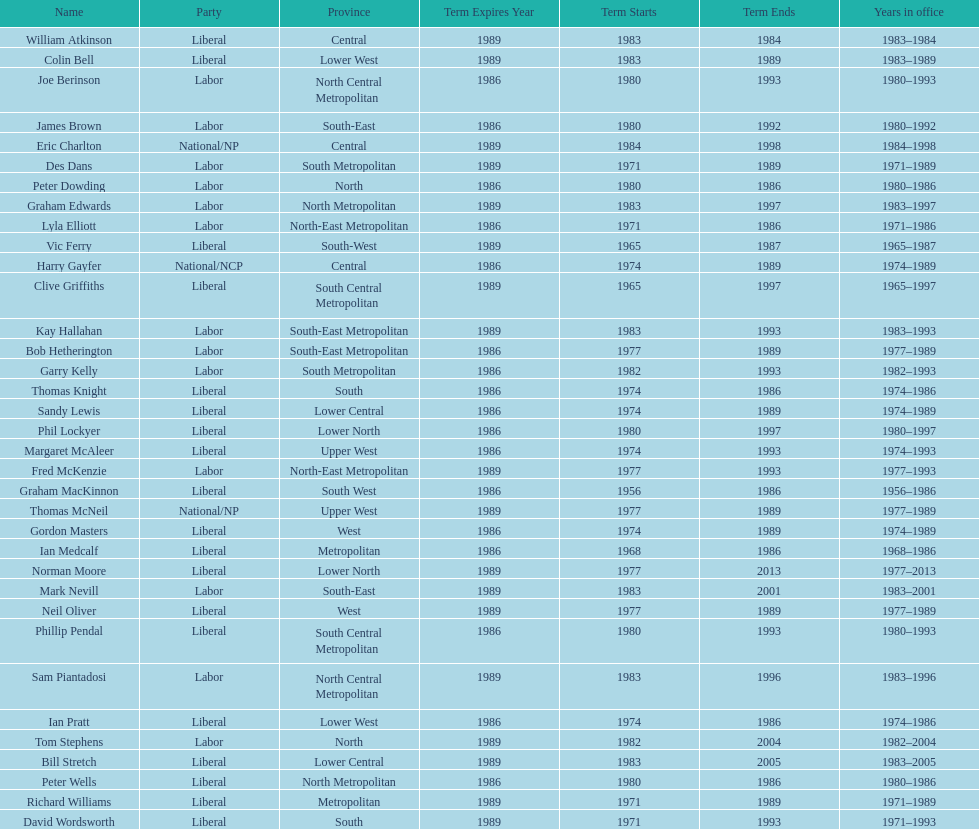What is the number of people in the liberal party? 19. Write the full table. {'header': ['Name', 'Party', 'Province', 'Term Expires Year', 'Term Starts', 'Term Ends', 'Years in office'], 'rows': [['William Atkinson', 'Liberal', 'Central', '1989', '1983', '1984', '1983–1984'], ['Colin Bell', 'Liberal', 'Lower West', '1989', '1983', '1989', '1983–1989'], ['Joe Berinson', 'Labor', 'North Central Metropolitan', '1986', '1980', '1993', '1980–1993'], ['James Brown', 'Labor', 'South-East', '1986', '1980', '1992', '1980–1992'], ['Eric Charlton', 'National/NP', 'Central', '1989', '1984', '1998', '1984–1998'], ['Des Dans', 'Labor', 'South Metropolitan', '1989', '1971', '1989', '1971–1989'], ['Peter Dowding', 'Labor', 'North', '1986', '1980', '1986', '1980–1986'], ['Graham Edwards', 'Labor', 'North Metropolitan', '1989', '1983', '1997', '1983–1997'], ['Lyla Elliott', 'Labor', 'North-East Metropolitan', '1986', '1971', '1986', '1971–1986'], ['Vic Ferry', 'Liberal', 'South-West', '1989', '1965', '1987', '1965–1987'], ['Harry Gayfer', 'National/NCP', 'Central', '1986', '1974', '1989', '1974–1989'], ['Clive Griffiths', 'Liberal', 'South Central Metropolitan', '1989', '1965', '1997', '1965–1997'], ['Kay Hallahan', 'Labor', 'South-East Metropolitan', '1989', '1983', '1993', '1983–1993'], ['Bob Hetherington', 'Labor', 'South-East Metropolitan', '1986', '1977', '1989', '1977–1989'], ['Garry Kelly', 'Labor', 'South Metropolitan', '1986', '1982', '1993', '1982–1993'], ['Thomas Knight', 'Liberal', 'South', '1986', '1974', '1986', '1974–1986'], ['Sandy Lewis', 'Liberal', 'Lower Central', '1986', '1974', '1989', '1974–1989'], ['Phil Lockyer', 'Liberal', 'Lower North', '1986', '1980', '1997', '1980–1997'], ['Margaret McAleer', 'Liberal', 'Upper West', '1986', '1974', '1993', '1974–1993'], ['Fred McKenzie', 'Labor', 'North-East Metropolitan', '1989', '1977', '1993', '1977–1993'], ['Graham MacKinnon', 'Liberal', 'South West', '1986', '1956', '1986', '1956–1986'], ['Thomas McNeil', 'National/NP', 'Upper West', '1989', '1977', '1989', '1977–1989'], ['Gordon Masters', 'Liberal', 'West', '1986', '1974', '1989', '1974–1989'], ['Ian Medcalf', 'Liberal', 'Metropolitan', '1986', '1968', '1986', '1968–1986'], ['Norman Moore', 'Liberal', 'Lower North', '1989', '1977', '2013', '1977–2013'], ['Mark Nevill', 'Labor', 'South-East', '1989', '1983', '2001', '1983–2001'], ['Neil Oliver', 'Liberal', 'West', '1989', '1977', '1989', '1977–1989'], ['Phillip Pendal', 'Liberal', 'South Central Metropolitan', '1986', '1980', '1993', '1980–1993'], ['Sam Piantadosi', 'Labor', 'North Central Metropolitan', '1989', '1983', '1996', '1983–1996'], ['Ian Pratt', 'Liberal', 'Lower West', '1986', '1974', '1986', '1974–1986'], ['Tom Stephens', 'Labor', 'North', '1989', '1982', '2004', '1982–2004'], ['Bill Stretch', 'Liberal', 'Lower Central', '1989', '1983', '2005', '1983–2005'], ['Peter Wells', 'Liberal', 'North Metropolitan', '1986', '1980', '1986', '1980–1986'], ['Richard Williams', 'Liberal', 'Metropolitan', '1989', '1971', '1989', '1971–1989'], ['David Wordsworth', 'Liberal', 'South', '1989', '1971', '1993', '1971–1993']]} 